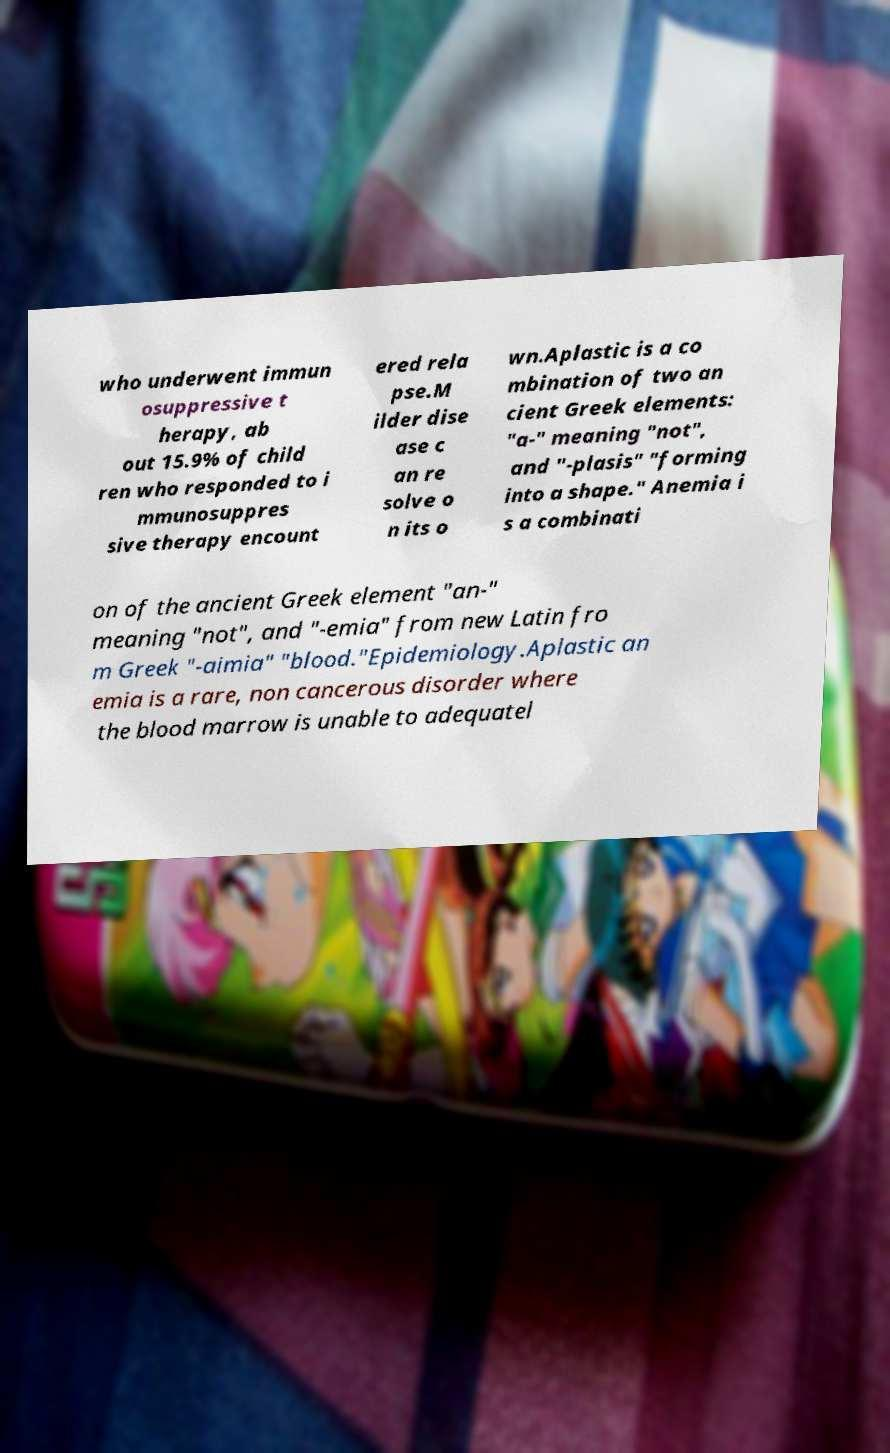Please identify and transcribe the text found in this image. who underwent immun osuppressive t herapy, ab out 15.9% of child ren who responded to i mmunosuppres sive therapy encount ered rela pse.M ilder dise ase c an re solve o n its o wn.Aplastic is a co mbination of two an cient Greek elements: "a-" meaning "not", and "-plasis" "forming into a shape." Anemia i s a combinati on of the ancient Greek element "an-" meaning "not", and "-emia" from new Latin fro m Greek "-aimia" "blood."Epidemiology.Aplastic an emia is a rare, non cancerous disorder where the blood marrow is unable to adequatel 